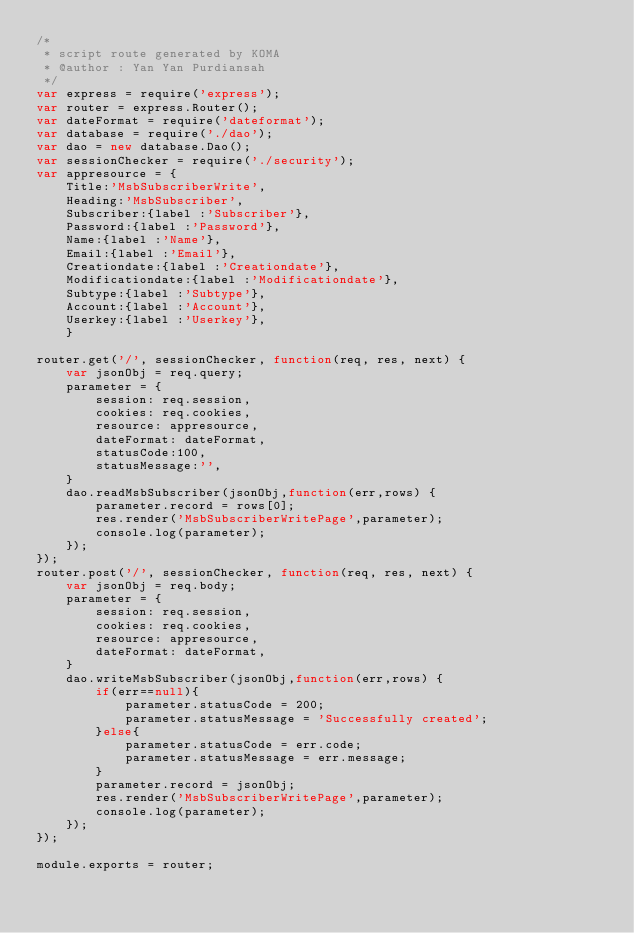Convert code to text. <code><loc_0><loc_0><loc_500><loc_500><_JavaScript_>/*
 * script route generated by KOMA
 * @author : Yan Yan Purdiansah
 */    
var express = require('express');
var router = express.Router();
var dateFormat = require('dateformat');    
var database = require('./dao');
var dao = new database.Dao();    
var sessionChecker = require('./security');
var appresource = {
    Title:'MsbSubscriberWrite',
    Heading:'MsbSubscriber',
    Subscriber:{label :'Subscriber'},
    Password:{label :'Password'},
    Name:{label :'Name'},
    Email:{label :'Email'},
    Creationdate:{label :'Creationdate'},
    Modificationdate:{label :'Modificationdate'},
    Subtype:{label :'Subtype'},
    Account:{label :'Account'},
    Userkey:{label :'Userkey'},
    }

router.get('/', sessionChecker, function(req, res, next) {
    var jsonObj = req.query;
    parameter = {
        session: req.session,
        cookies: req.cookies,
        resource: appresource,
        dateFormat: dateFormat,
        statusCode:100,
        statusMessage:'',
    }
    dao.readMsbSubscriber(jsonObj,function(err,rows) {
        parameter.record = rows[0];
        res.render('MsbSubscriberWritePage',parameter);
        console.log(parameter);        
    });
});
router.post('/', sessionChecker, function(req, res, next) {
    var jsonObj = req.body;
    parameter = {
        session: req.session,
        cookies: req.cookies,
        resource: appresource,
        dateFormat: dateFormat,        
    }
    dao.writeMsbSubscriber(jsonObj,function(err,rows) {    
        if(err==null){
            parameter.statusCode = 200;
            parameter.statusMessage = 'Successfully created';
        }else{
            parameter.statusCode = err.code;
            parameter.statusMessage = err.message;
        }
        parameter.record = jsonObj;
        res.render('MsbSubscriberWritePage',parameter);
        console.log(parameter);        
    });
});

module.exports = router;
</code> 